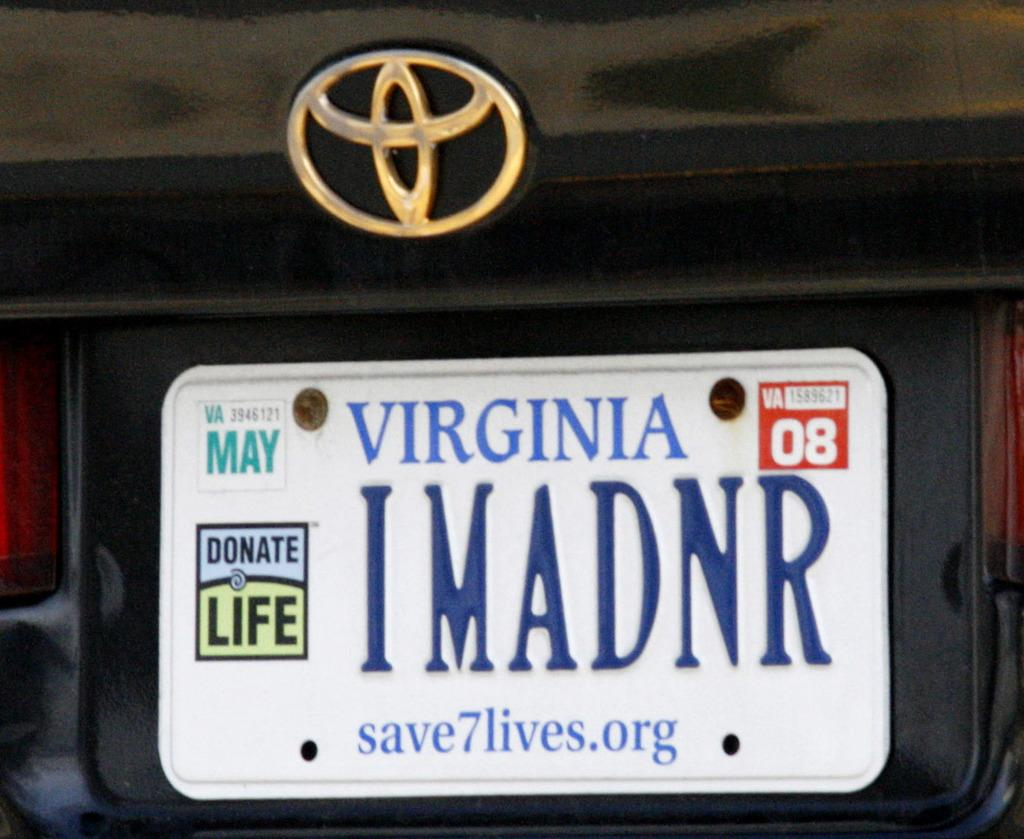<image>
Present a compact description of the photo's key features. a virginia name on a license plate on a car 